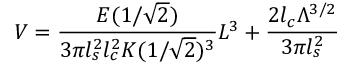<formula> <loc_0><loc_0><loc_500><loc_500>V = \frac { E ( 1 / \sqrt { 2 } ) } { 3 \pi l _ { s } ^ { 2 } l _ { c } ^ { 2 } K ( 1 / \sqrt { 2 } ) ^ { 3 } } L ^ { 3 } + \frac { 2 l _ { c } \Lambda ^ { 3 / 2 } } { 3 \pi l _ { s } ^ { 2 } }</formula> 